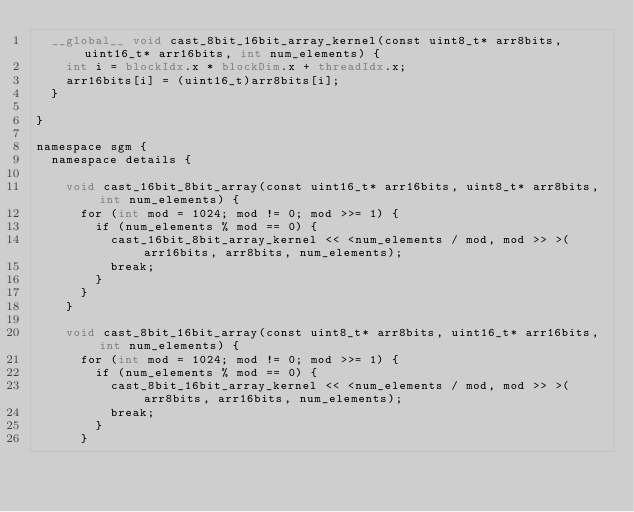<code> <loc_0><loc_0><loc_500><loc_500><_Cuda_>	__global__ void cast_8bit_16bit_array_kernel(const uint8_t* arr8bits, uint16_t* arr16bits, int num_elements) {
		int i = blockIdx.x * blockDim.x + threadIdx.x;
		arr16bits[i] = (uint16_t)arr8bits[i];
	}

}

namespace sgm {
	namespace details {

		void cast_16bit_8bit_array(const uint16_t* arr16bits, uint8_t* arr8bits, int num_elements) {
			for (int mod = 1024; mod != 0; mod >>= 1) {
				if (num_elements % mod == 0) {
					cast_16bit_8bit_array_kernel << <num_elements / mod, mod >> >(arr16bits, arr8bits, num_elements);
					break;
				}
			}
		}

		void cast_8bit_16bit_array(const uint8_t* arr8bits, uint16_t* arr16bits, int num_elements) {
			for (int mod = 1024; mod != 0; mod >>= 1) {
				if (num_elements % mod == 0) {
					cast_8bit_16bit_array_kernel << <num_elements / mod, mod >> >(arr8bits, arr16bits, num_elements);
					break;
				}
			}</code> 